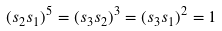<formula> <loc_0><loc_0><loc_500><loc_500>( s _ { 2 } s _ { 1 } ) ^ { 5 } = ( s _ { 3 } s _ { 2 } ) ^ { 3 } = ( s _ { 3 } s _ { 1 } ) ^ { 2 } = 1</formula> 